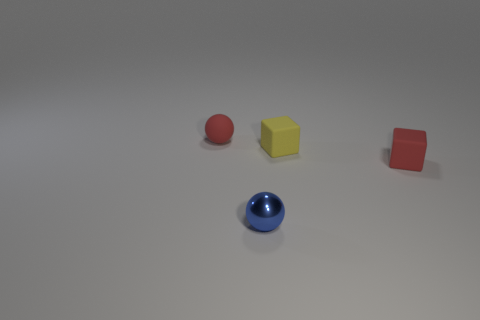Is there anything else that has the same material as the tiny blue thing?
Give a very brief answer. No. What number of objects are either rubber things that are on the left side of the blue metallic object or spheres on the left side of the blue shiny object?
Offer a terse response. 1. Is the number of yellow rubber objects that are on the left side of the blue shiny ball greater than the number of tiny red rubber blocks that are behind the red rubber ball?
Give a very brief answer. No. What is the red thing in front of the small thing that is left of the small sphere in front of the red cube made of?
Make the answer very short. Rubber. There is a red object that is right of the yellow cube; is it the same shape as the blue shiny thing in front of the yellow rubber object?
Keep it short and to the point. No. Are there any metal balls that have the same size as the shiny thing?
Ensure brevity in your answer.  No. What number of purple objects are small matte spheres or balls?
Give a very brief answer. 0. What number of rubber objects have the same color as the matte sphere?
Your answer should be compact. 1. Is there anything else that has the same shape as the small yellow thing?
Ensure brevity in your answer.  Yes. What number of cubes are matte things or tiny yellow rubber things?
Provide a succinct answer. 2. 